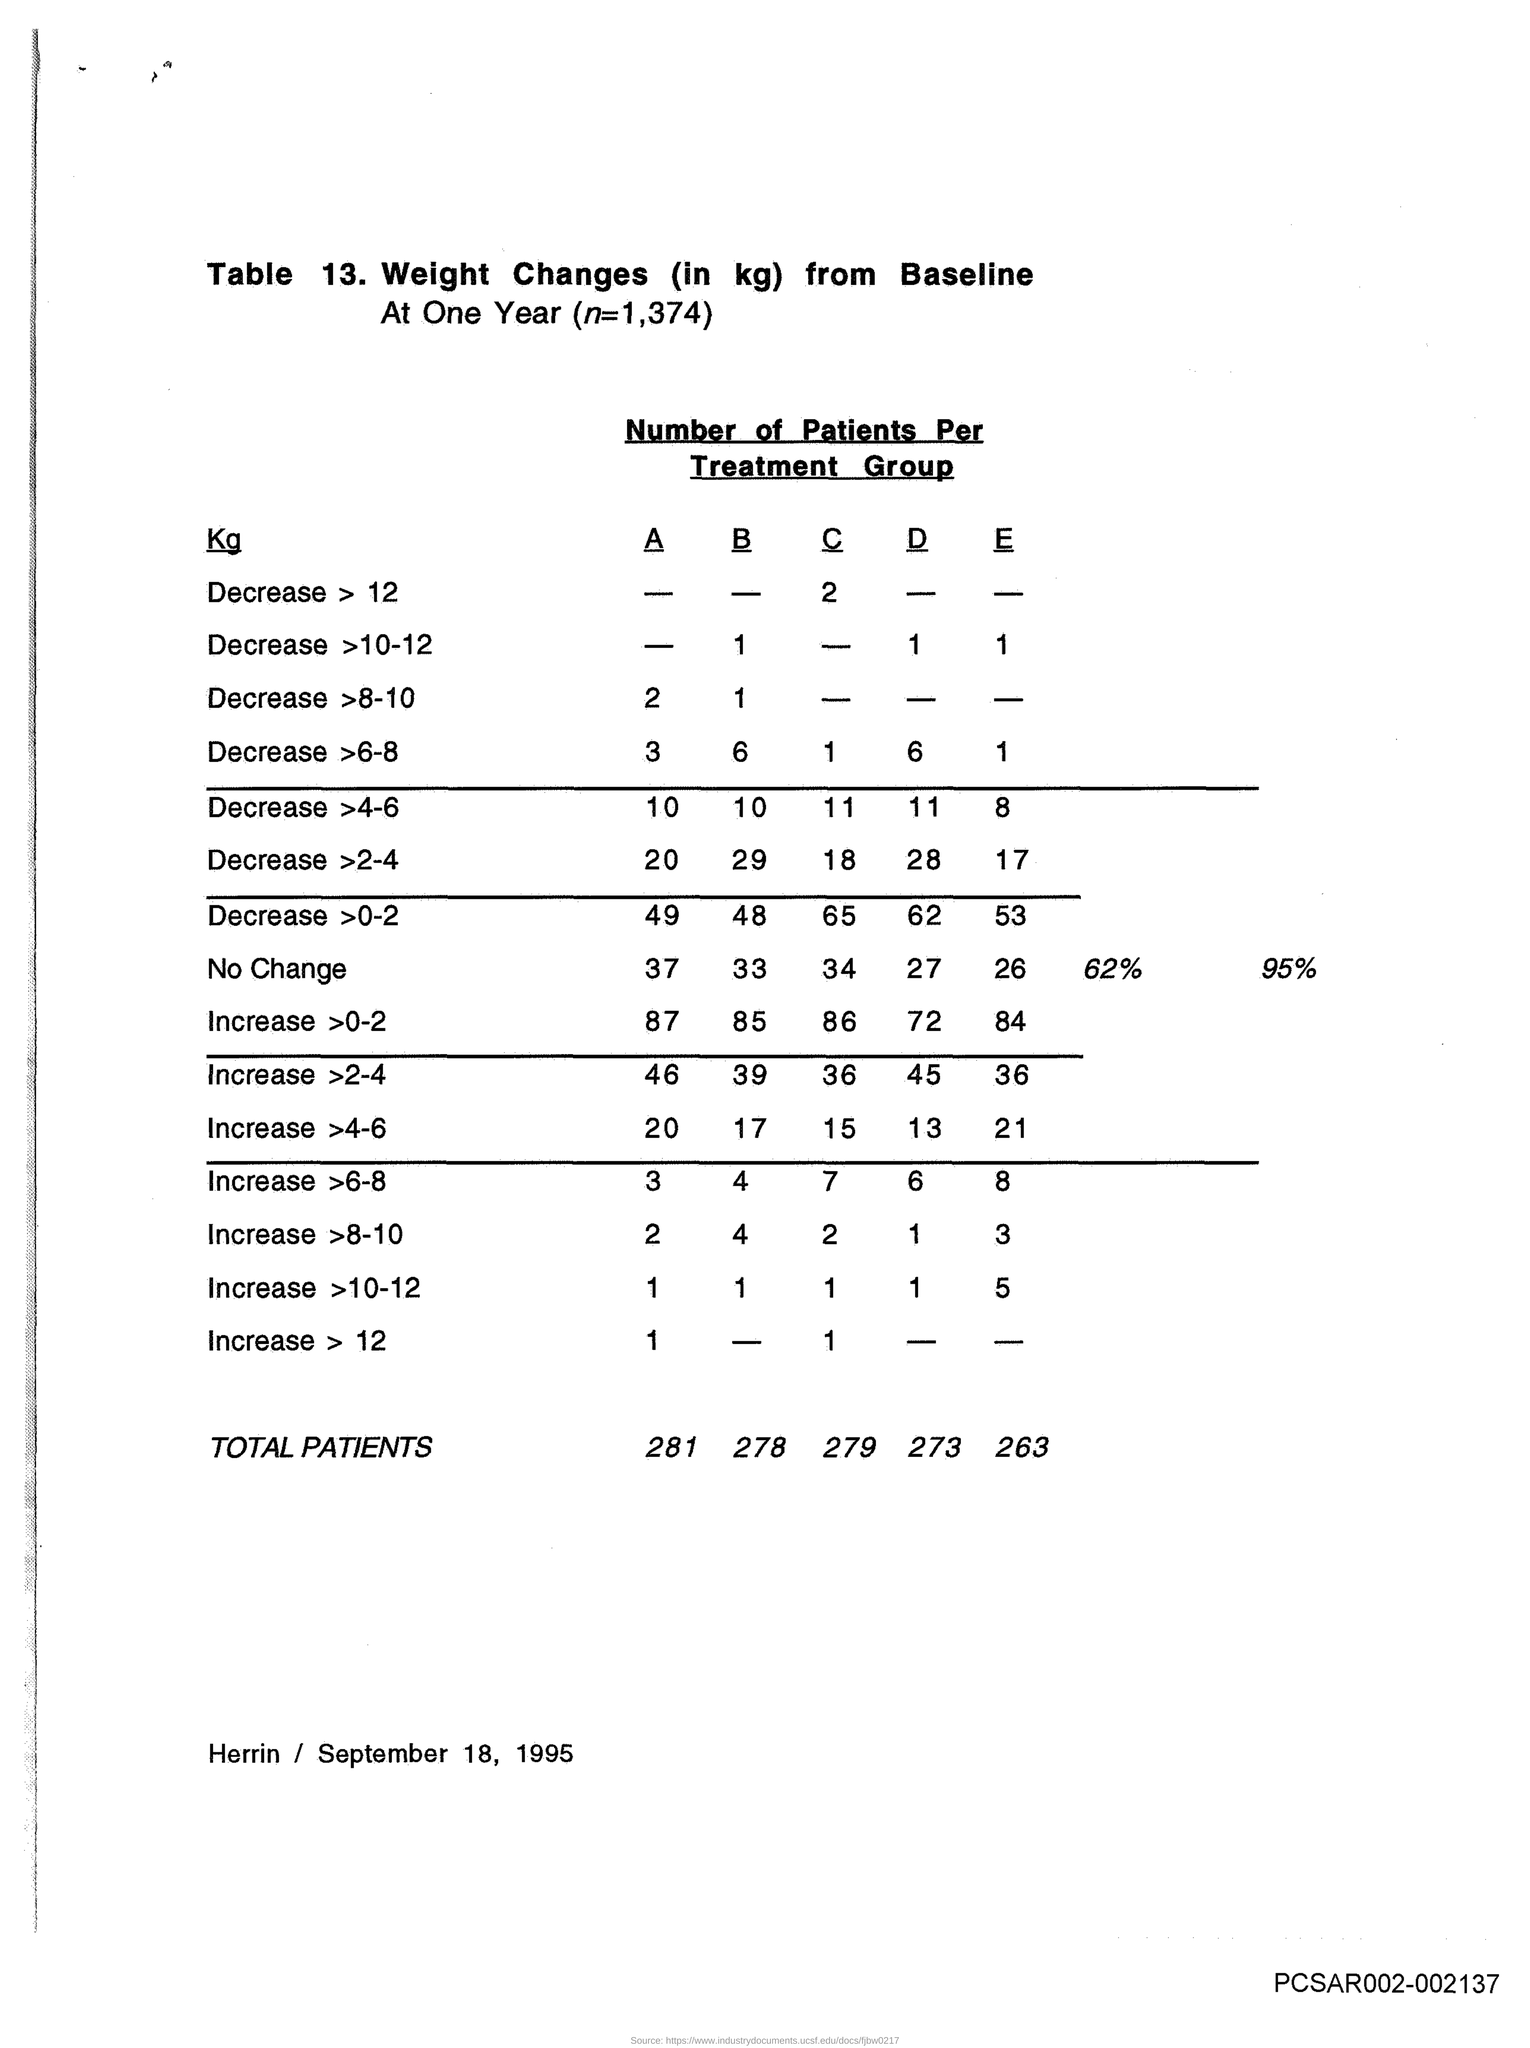Indicate a few pertinent items in this graphic. The total number of patients in group B is 278. The value of n is 1,374. Please provide the table number, which is 13... The document mentions that the date is September 18, 1995. The total number of patients in group A is 281. 